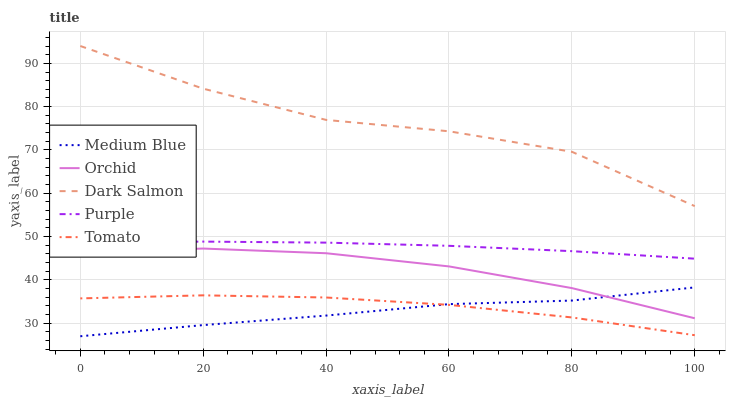Does Medium Blue have the minimum area under the curve?
Answer yes or no. Yes. Does Dark Salmon have the maximum area under the curve?
Answer yes or no. Yes. Does Tomato have the minimum area under the curve?
Answer yes or no. No. Does Tomato have the maximum area under the curve?
Answer yes or no. No. Is Purple the smoothest?
Answer yes or no. Yes. Is Dark Salmon the roughest?
Answer yes or no. Yes. Is Tomato the smoothest?
Answer yes or no. No. Is Tomato the roughest?
Answer yes or no. No. Does Tomato have the lowest value?
Answer yes or no. No. Does Dark Salmon have the highest value?
Answer yes or no. Yes. Does Medium Blue have the highest value?
Answer yes or no. No. Is Orchid less than Purple?
Answer yes or no. Yes. Is Dark Salmon greater than Orchid?
Answer yes or no. Yes. Does Medium Blue intersect Orchid?
Answer yes or no. Yes. Is Medium Blue less than Orchid?
Answer yes or no. No. Is Medium Blue greater than Orchid?
Answer yes or no. No. Does Orchid intersect Purple?
Answer yes or no. No. 